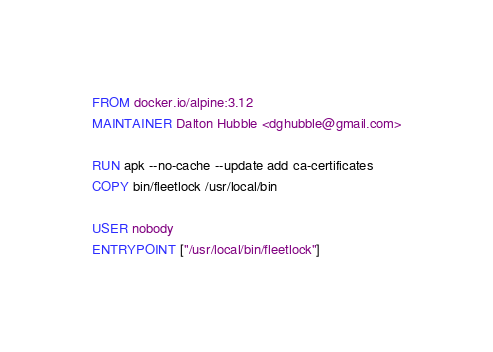<code> <loc_0><loc_0><loc_500><loc_500><_Dockerfile_>FROM docker.io/alpine:3.12
MAINTAINER Dalton Hubble <dghubble@gmail.com>

RUN apk --no-cache --update add ca-certificates
COPY bin/fleetlock /usr/local/bin

USER nobody
ENTRYPOINT ["/usr/local/bin/fleetlock"]

</code> 